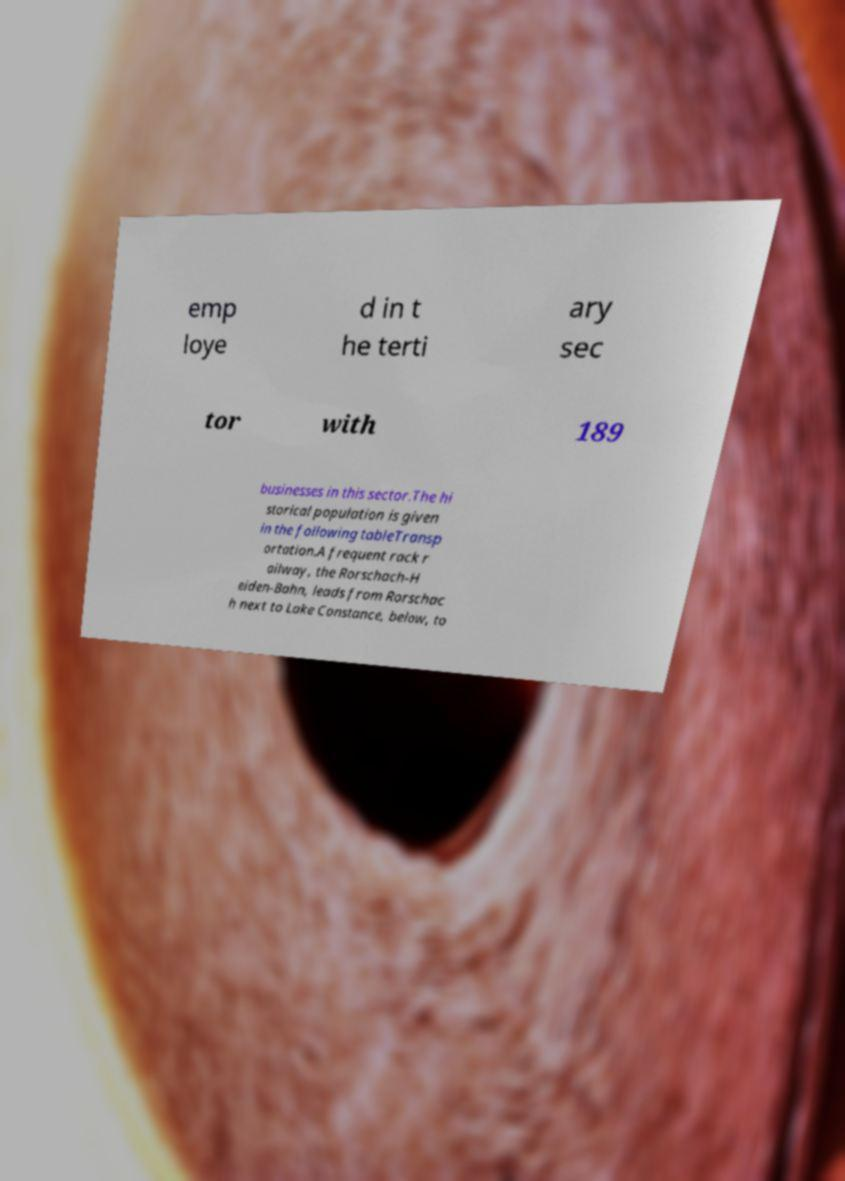I need the written content from this picture converted into text. Can you do that? emp loye d in t he terti ary sec tor with 189 businesses in this sector.The hi storical population is given in the following tableTransp ortation.A frequent rack r ailway, the Rorschach-H eiden-Bahn, leads from Rorschac h next to Lake Constance, below, to 